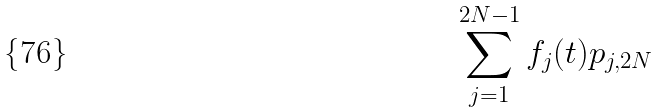<formula> <loc_0><loc_0><loc_500><loc_500>\sum _ { j = 1 } ^ { 2 N - 1 } f _ { j } ( t ) p _ { j , 2 N }</formula> 